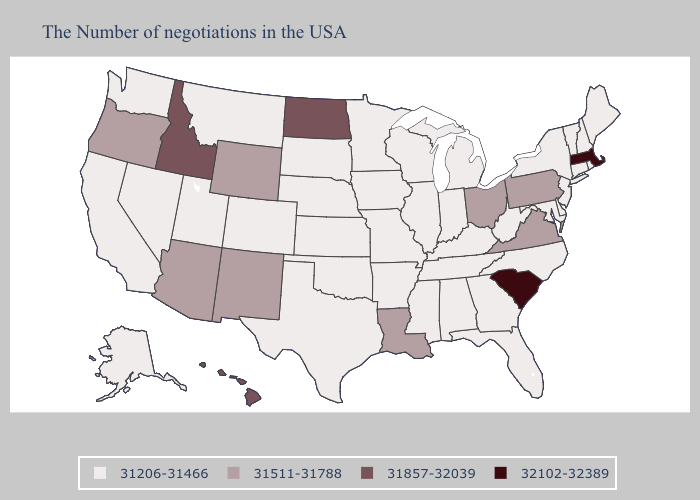What is the value of Massachusetts?
Short answer required. 32102-32389. Does Massachusetts have the lowest value in the USA?
Short answer required. No. What is the value of Kentucky?
Quick response, please. 31206-31466. Name the states that have a value in the range 31857-32039?
Keep it brief. North Dakota, Idaho, Hawaii. Does Louisiana have the highest value in the South?
Short answer required. No. Among the states that border Washington , does Oregon have the highest value?
Keep it brief. No. Does Kansas have the lowest value in the USA?
Be succinct. Yes. How many symbols are there in the legend?
Answer briefly. 4. What is the value of Hawaii?
Quick response, please. 31857-32039. Name the states that have a value in the range 32102-32389?
Quick response, please. Massachusetts, South Carolina. Name the states that have a value in the range 31511-31788?
Concise answer only. Pennsylvania, Virginia, Ohio, Louisiana, Wyoming, New Mexico, Arizona, Oregon. Does Arkansas have the same value as Indiana?
Short answer required. Yes. What is the value of Colorado?
Answer briefly. 31206-31466. Among the states that border Arizona , which have the lowest value?
Concise answer only. Colorado, Utah, Nevada, California. Does the map have missing data?
Write a very short answer. No. 